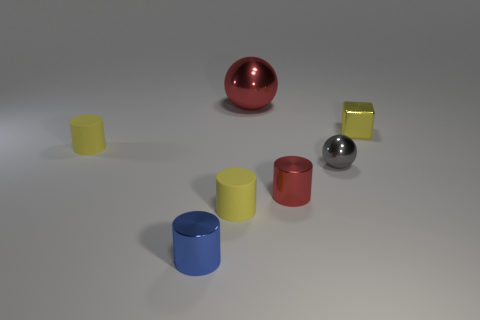What number of other things are there of the same shape as the small red metal thing? There are three objects of the same cylindrical shape as the small red metal cylinder. These include a yellow, a blue, and another red cylinder, all varying in size and positioned at different points in the scene. 